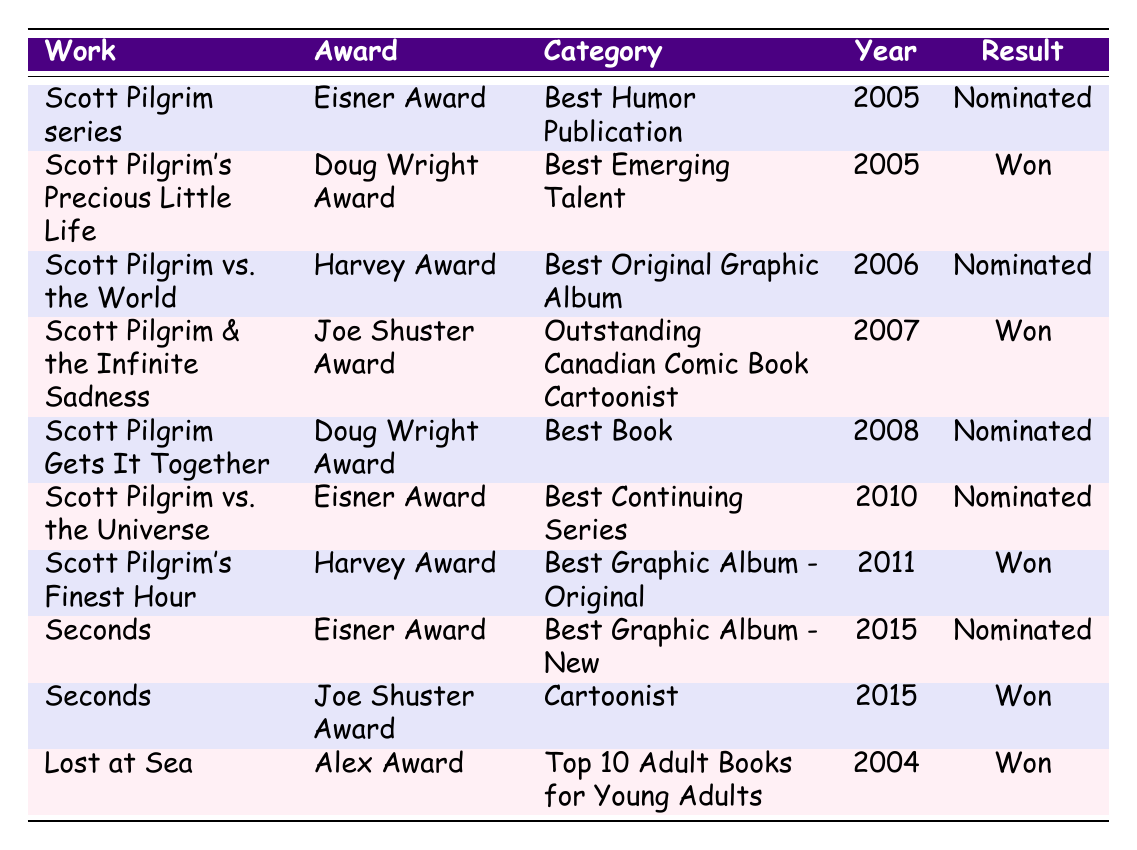What award did "Scott Pilgrim's Precious Little Life" win? The table shows that "Scott Pilgrim's Precious Little Life" won the Doug Wright Award in the category of Best Emerging Talent in 2005.
Answer: Doug Wright Award How many works received nominations for the Eisner Award? The table lists three works that received Eisner Award nominations: "Scott Pilgrim series" in 2005, "Scott Pilgrim vs. the Universe" in 2010, and "Seconds" in 2015. Thus, there are three works in total that were nominated.
Answer: 3 Was "Lost at Sea" nominated for any award? The table indicates that "Lost at Sea" won the Alex Award in 2004, thus it was not nominated for any award.
Answer: No What is the total number of awards won by Bryan Lee O'Malley's works? By adding the wins from the table: 1 for "Scott Pilgrim's Precious Little Life," 1 for "Scott Pilgrim & the Infinite Sadness," 1 for "Scott Pilgrim's Finest Hour," 1 for "Seconds," and 1 for "Lost at Sea," we find a total of 5 awards won.
Answer: 5 How many awards were won before the year 2010? The table shows that the awards won before 2010 are: "Lost at Sea" in 2004, "Scott Pilgrim's Precious Little Life" in 2005, and "Scott Pilgrim & the Infinite Sadness" in 2007. That totals three awards won before 2010.
Answer: 3 Did Bryan Lee O'Malley receive the Harvey Award for "Scott Pilgrim vs. the World"? According to the table, "Scott Pilgrim vs. the World" was nominated for the Harvey Award in 2006 but did not win it.
Answer: No Which work had the most recent award win? The most recent work to win an award is "Seconds," which won the Joe Shuster Award in the category of Cartoonist in 2015.
Answer: Seconds In which year did the most awards win occur? The years with awards won are 2004 (1), 2005 (1), 2007 (1), 2011 (1), and 2015 (2). The year 2015 had the highest number of wins, with two awards.
Answer: 2015 